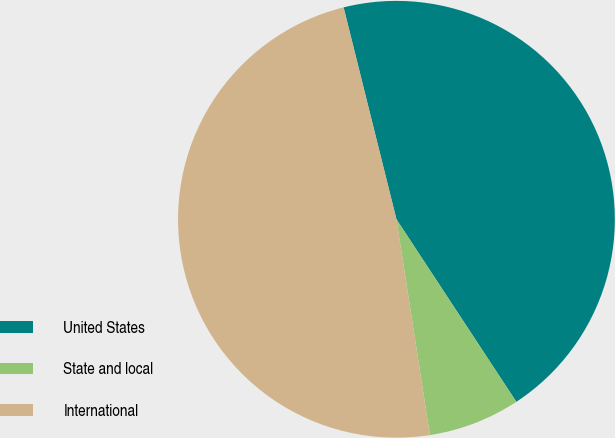Convert chart to OTSL. <chart><loc_0><loc_0><loc_500><loc_500><pie_chart><fcel>United States<fcel>State and local<fcel>International<nl><fcel>44.64%<fcel>6.8%<fcel>48.56%<nl></chart> 